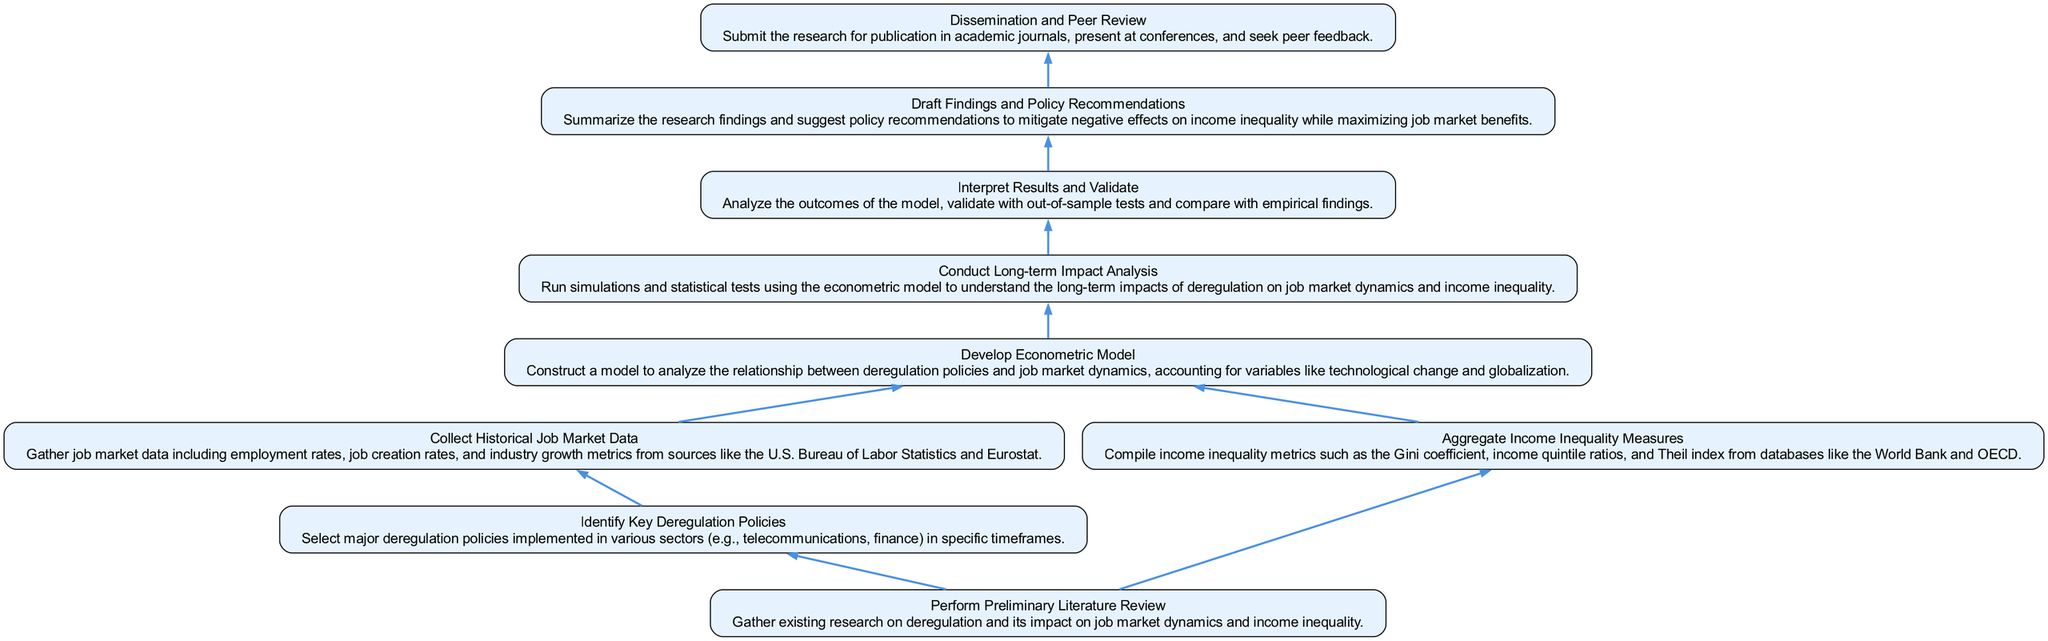What is the first step in the flow chart? The first node in the flow chart is "Perform Preliminary Literature Review," which indicates that gathering existing research is the initial step.
Answer: Perform Preliminary Literature Review How many decisions or processes are shown in the diagram? By counting each node, there are a total of eight distinct processes in the flow chart, which include steps from literature review to dissemination.
Answer: 8 Which step follows "Conduct Long-term Impact Analysis"? The next step in the flow chart after "Conduct Long-term Impact Analysis" is "Interpret Results and Validate," indicating that results interpretation comes after analysis.
Answer: Interpret Results and Validate What are the dependencies for "Develop Econometric Model"? To identify the dependencies, we look for nodes that lead into "Develop Econometric Model," which are "Collect Historical Job Market Data" and "Aggregate Income Inequality Measures."
Answer: Collect Historical Job Market Data, Aggregate Income Inequality Measures Which node leads directly to the "Dissemination and Peer Review"? The node that leads directly into "Dissemination and Peer Review" is "Draft Findings and Policy Recommendations," demonstrating that drafting findings must occur before dissemination.
Answer: Draft Findings and Policy Recommendations What is the last step of the process in the flow chart? The final node in the flow chart depicts "Dissemination and Peer Review," showing that the process concludes with sharing findings publicly.
Answer: Dissemination and Peer Review How many steps are required before conducting the long-term impact analysis? To find out how many steps lead to "Conduct Long-term Impact Analysis," we trace back to the previous node, "Develop Econometric Model," which has several required steps, totaling four before conducting the analysis.
Answer: 4 What is the relationship between "Collect Historical Job Market Data" and "Aggregate Income Inequality Measures"? Both nodes feed into the "Develop Econometric Model," establishing a causal relationship where data collection is essential for building the model.
Answer: They both feed into Develop Econometric Model Which of the following steps requires validation: "Interpret Results" or "Draft Findings"? "Interpret Results and Validate" is the step that explicitly involves validation, while "Draft Findings" focuses on summarizing research without direct validation.
Answer: Interpret Results and Validate 